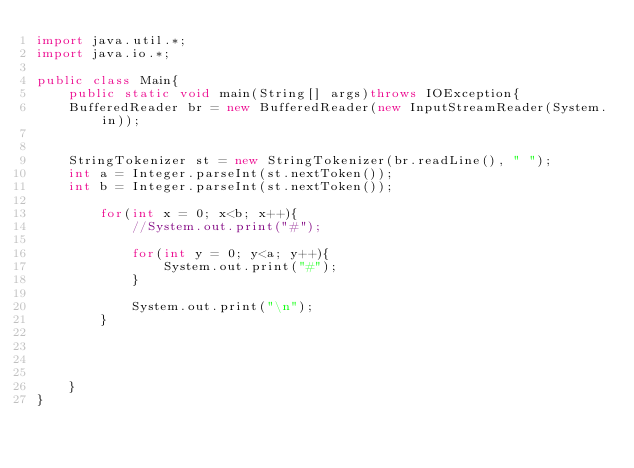Convert code to text. <code><loc_0><loc_0><loc_500><loc_500><_Java_>import java.util.*;
import java.io.*;

public class Main{
    public static void main(String[] args)throws IOException{
    BufferedReader br = new BufferedReader(new InputStreamReader(System.in));
    
    
    StringTokenizer st = new StringTokenizer(br.readLine(), " ");
    int a = Integer.parseInt(st.nextToken());
    int b = Integer.parseInt(st.nextToken());
    
        for(int x = 0; x<b; x++){
            //System.out.print("#");
            
            for(int y = 0; y<a; y++){
                System.out.print("#");
            }
            
            System.out.print("\n");
        }
    
    
    
    
    }
}</code> 